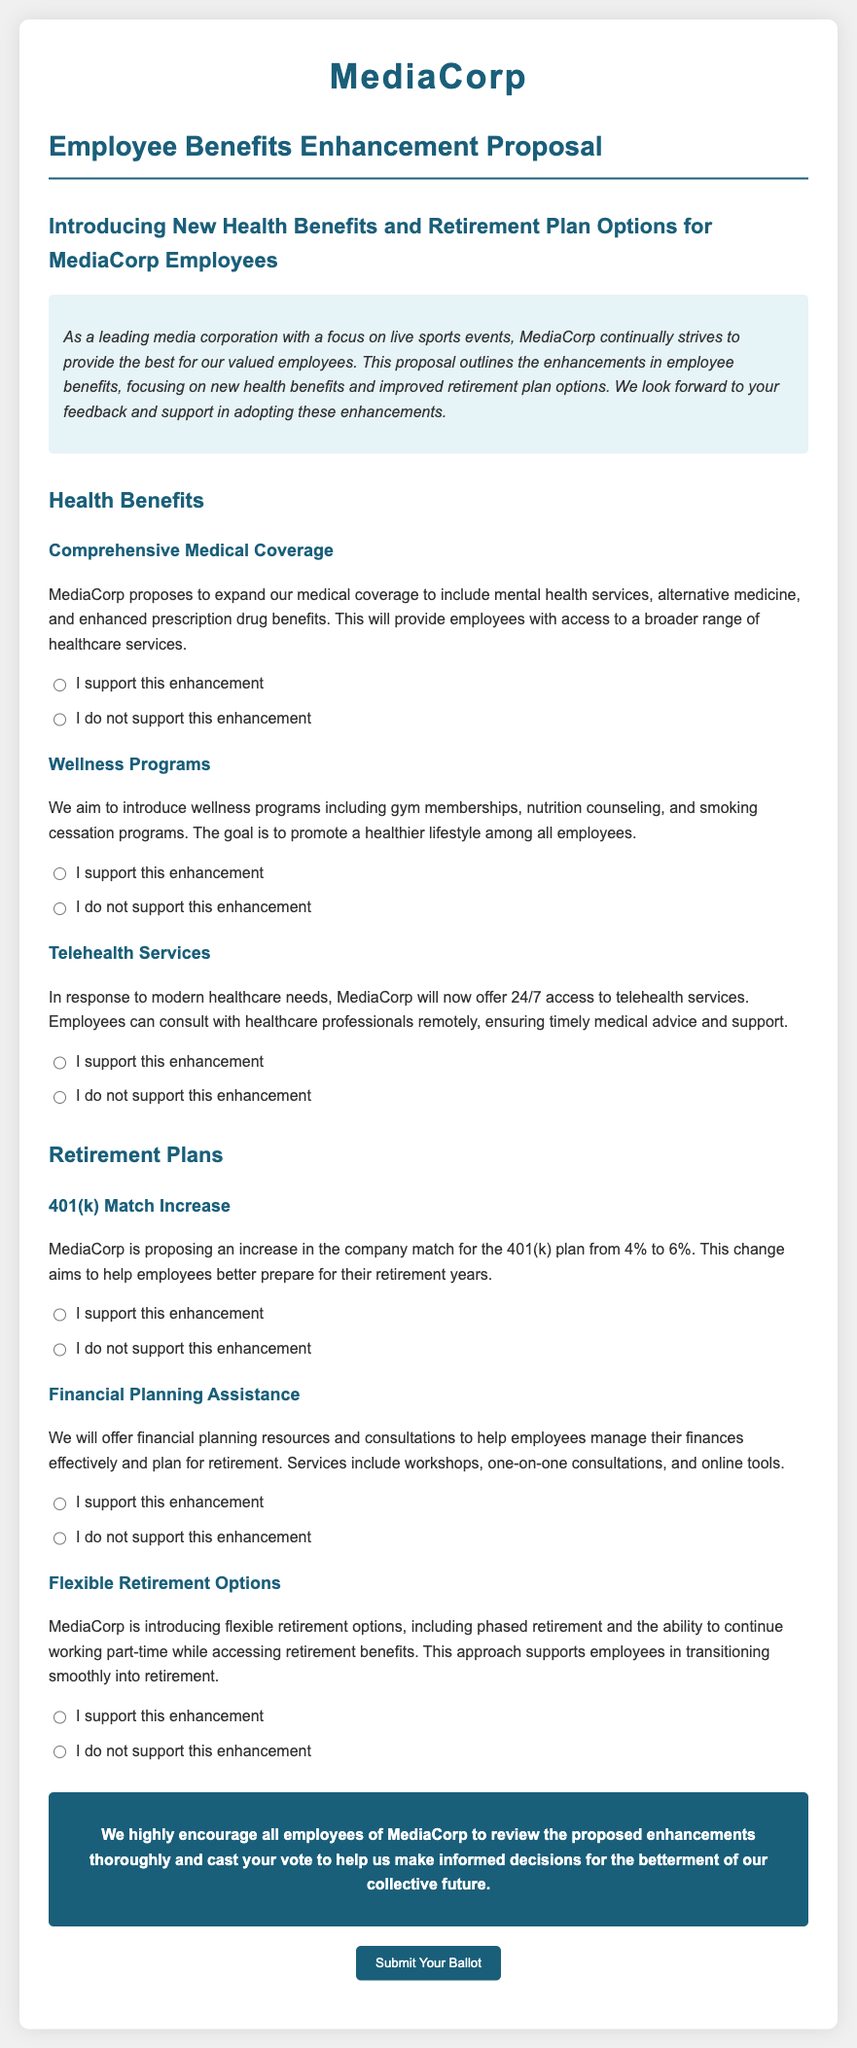What is the name of the corporation? The name of the corporation discussed in the document is MediaCorp.
Answer: MediaCorp What percentage will the 401(k) match increase to? The document states that the proposal is to increase the company match for the 401(k) plan from 4% to 6%.
Answer: 6% What new service offers 24/7 access? The proposal introduces telehealth services which allow for 24/7 access.
Answer: Telehealth services Which wellness program includes nutrition counseling? The wellness program mentioned specifically includes nutrition counseling as one of its features.
Answer: Nutrition counseling What is the goal of the proposed wellness programs? The goal of the wellness programs is to promote a healthier lifestyle among all employees.
Answer: Promote a healthier lifestyle How many health benefits enhancements are proposed? The document outlines three health benefits enhancements: comprehensive medical coverage, wellness programs, and telehealth services.
Answer: Three What kind of financial service is included for retirement plans? The proposal includes financial planning resources and consultations to help employees manage their finances for retirement.
Answer: Financial planning resources What options are introduced to support retirement transition? Flexible retirement options like phased retirement and part-time work while accessing benefits are introduced to support this transition.
Answer: Flexible retirement options 